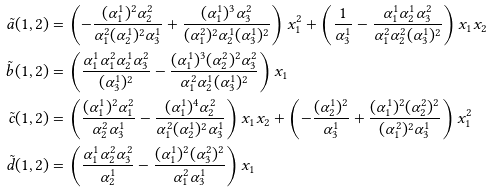Convert formula to latex. <formula><loc_0><loc_0><loc_500><loc_500>\tilde { a } ( 1 , 2 ) & = \left ( - \frac { ( \alpha _ { 1 } ^ { 1 } ) ^ { 2 } \alpha _ { 2 } ^ { 2 } } { \alpha _ { 1 } ^ { 2 } ( \alpha _ { 2 } ^ { 1 } ) ^ { 2 } \alpha _ { 3 } ^ { 1 } } + \frac { ( \alpha _ { 1 } ^ { 1 } ) ^ { 3 } \alpha _ { 3 } ^ { 2 } } { ( \alpha _ { 1 } ^ { 2 } ) ^ { 2 } \alpha _ { 2 } ^ { 1 } ( \alpha _ { 3 } ^ { 1 } ) ^ { 2 } } \right ) x _ { 1 } ^ { 2 } + \left ( \frac { 1 } { \alpha _ { 3 } ^ { 1 } } - \frac { \alpha _ { 1 } ^ { 1 } \alpha _ { 2 } ^ { 1 } \alpha _ { 3 } ^ { 2 } } { \alpha _ { 1 } ^ { 2 } \alpha _ { 2 } ^ { 2 } ( \alpha _ { 3 } ^ { 1 } ) ^ { 2 } } \right ) x _ { 1 } x _ { 2 } \\ \tilde { b } ( 1 , 2 ) & = \left ( \frac { \alpha _ { 1 } ^ { 1 } \alpha _ { 1 } ^ { 2 } \alpha _ { 2 } ^ { 1 } \alpha _ { 3 } ^ { 2 } } { ( \alpha _ { 3 } ^ { 1 } ) ^ { 2 } } - \frac { ( \alpha _ { 1 } ^ { 1 } ) ^ { 3 } ( \alpha _ { 2 } ^ { 2 } ) ^ { 2 } \alpha _ { 3 } ^ { 2 } } { \alpha _ { 1 } ^ { 2 } \alpha _ { 2 } ^ { 1 } ( \alpha _ { 3 } ^ { 1 } ) ^ { 2 } } \right ) x _ { 1 } \\ \tilde { c } ( 1 , 2 ) & = \left ( \frac { ( \alpha _ { 1 } ^ { 1 } ) ^ { 2 } \alpha _ { 1 } ^ { 2 } } { \alpha _ { 2 } ^ { 2 } \alpha _ { 3 } ^ { 1 } } - \frac { ( \alpha _ { 1 } ^ { 1 } ) ^ { 4 } \alpha _ { 2 } ^ { 2 } } { \alpha _ { 1 } ^ { 2 } ( \alpha _ { 2 } ^ { 1 } ) ^ { 2 } \alpha _ { 3 } ^ { 1 } } \right ) x _ { 1 } x _ { 2 } + \left ( - \frac { ( \alpha _ { 2 } ^ { 1 } ) ^ { 2 } } { \alpha _ { 3 } ^ { 1 } } + \frac { ( \alpha _ { 1 } ^ { 1 } ) ^ { 2 } ( \alpha _ { 2 } ^ { 2 } ) ^ { 2 } } { ( \alpha _ { 1 } ^ { 2 } ) ^ { 2 } \alpha _ { 3 } ^ { 1 } } \right ) x _ { 1 } ^ { 2 } \\ \tilde { d } ( 1 , 2 ) & = \left ( \frac { \alpha _ { 1 } ^ { 1 } \alpha _ { 2 } ^ { 2 } \alpha _ { 3 } ^ { 2 } } { \alpha _ { 2 } ^ { 1 } } - \frac { ( \alpha _ { 1 } ^ { 1 } ) ^ { 2 } ( \alpha _ { 3 } ^ { 2 } ) ^ { 2 } } { \alpha _ { 1 } ^ { 2 } \alpha _ { 3 } ^ { 1 } } \right ) x _ { 1 }</formula> 